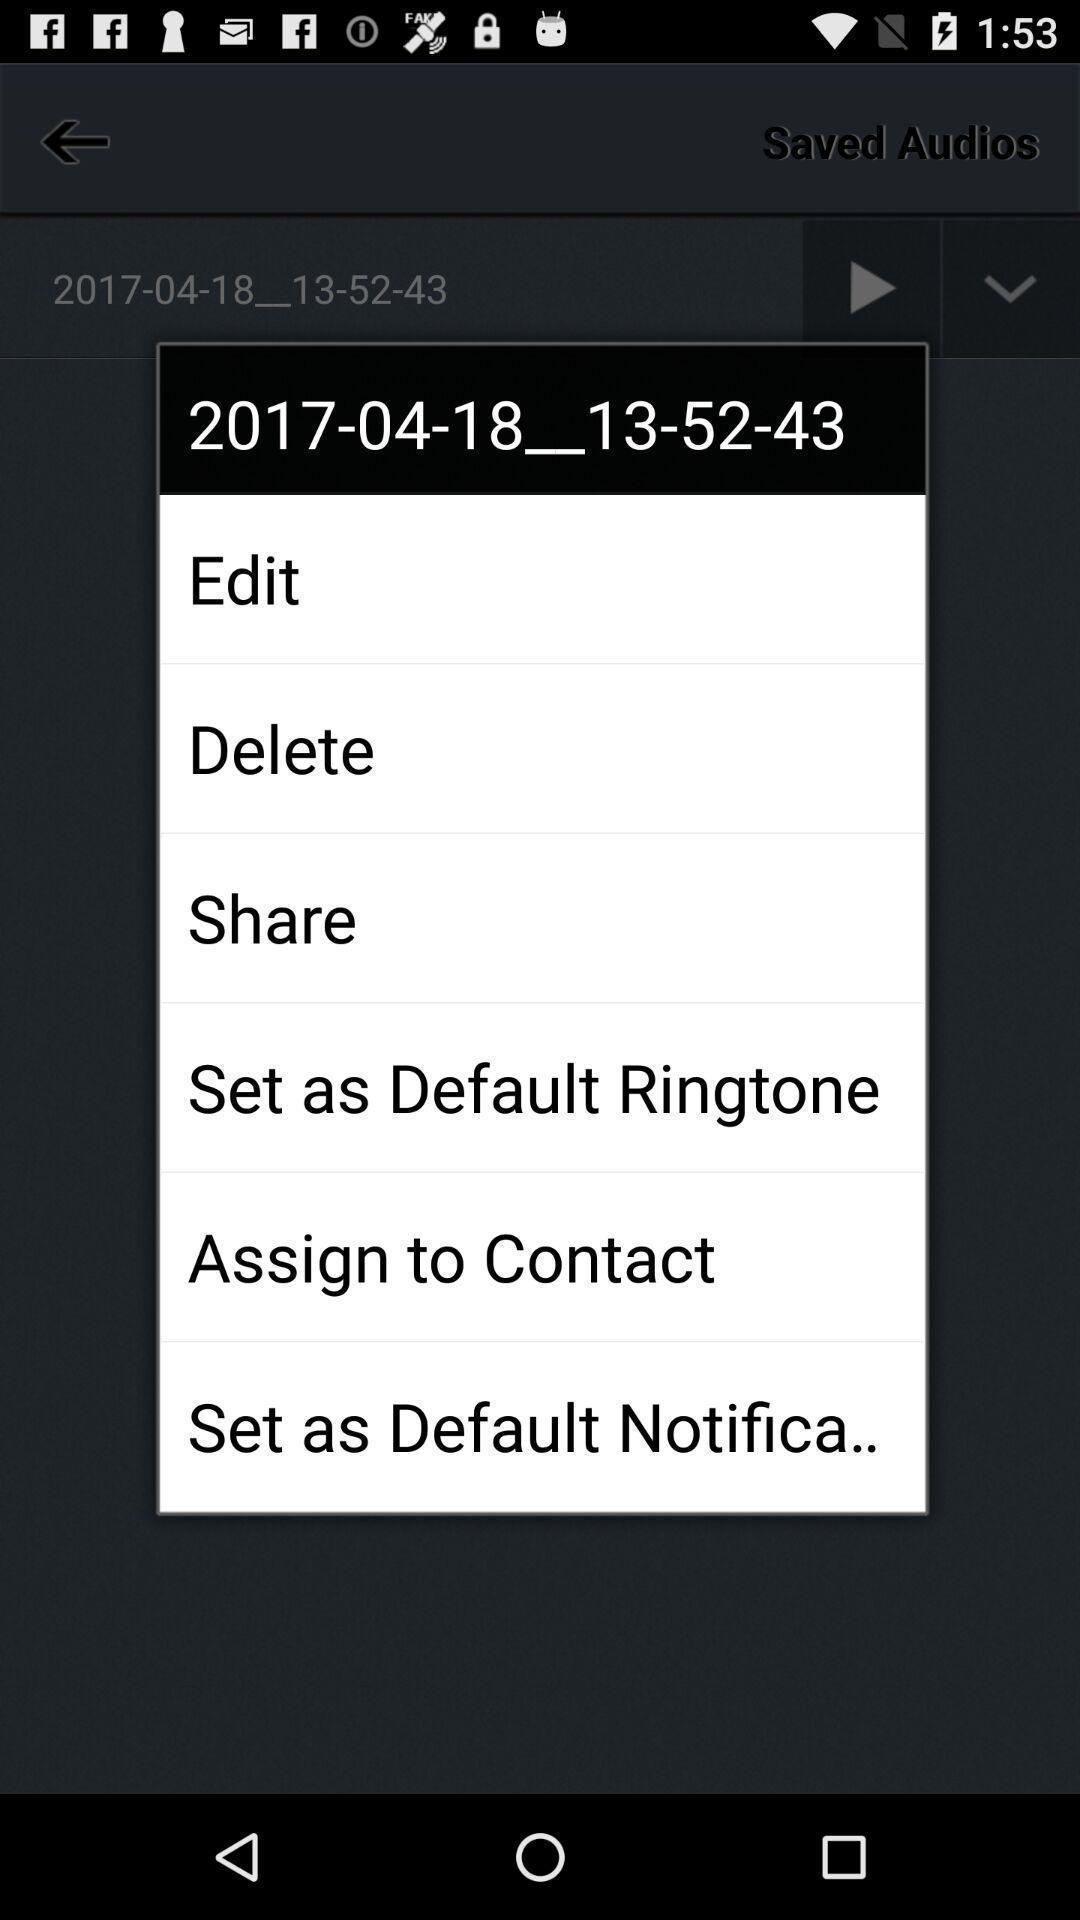What is the overall content of this screenshot? Screen displaying list of options for ringtone. 